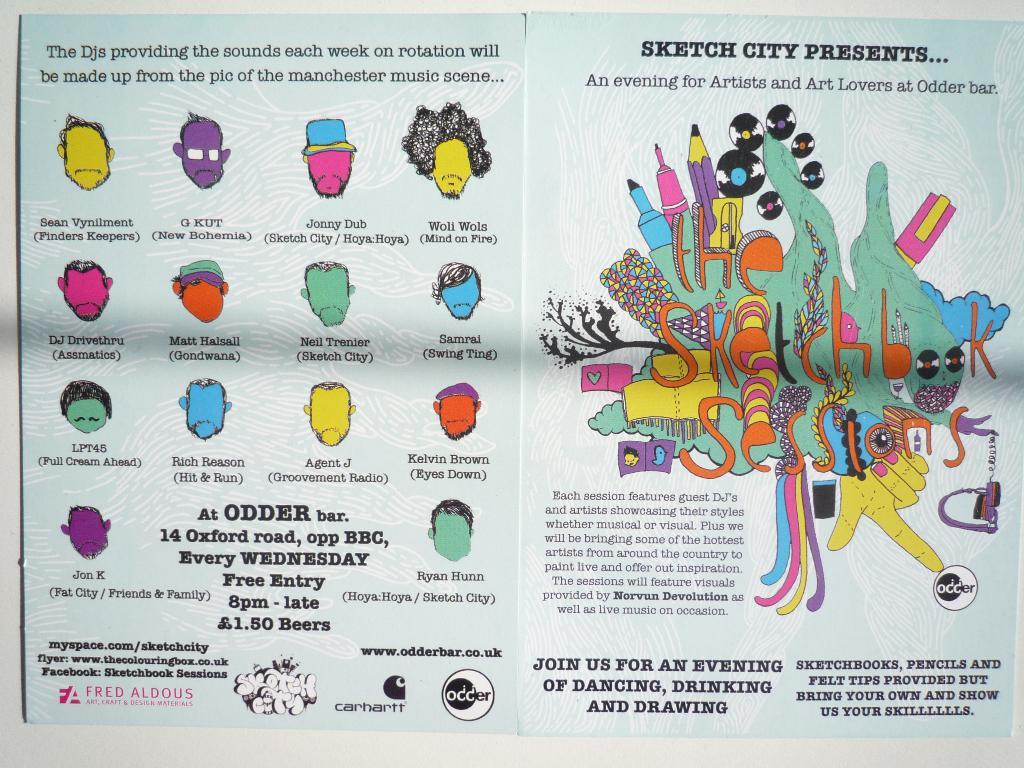What is the name of the event?
Offer a terse response. An evening for artists and art lovers at odder bar. What time does the event start?
Keep it short and to the point. 8pm. 